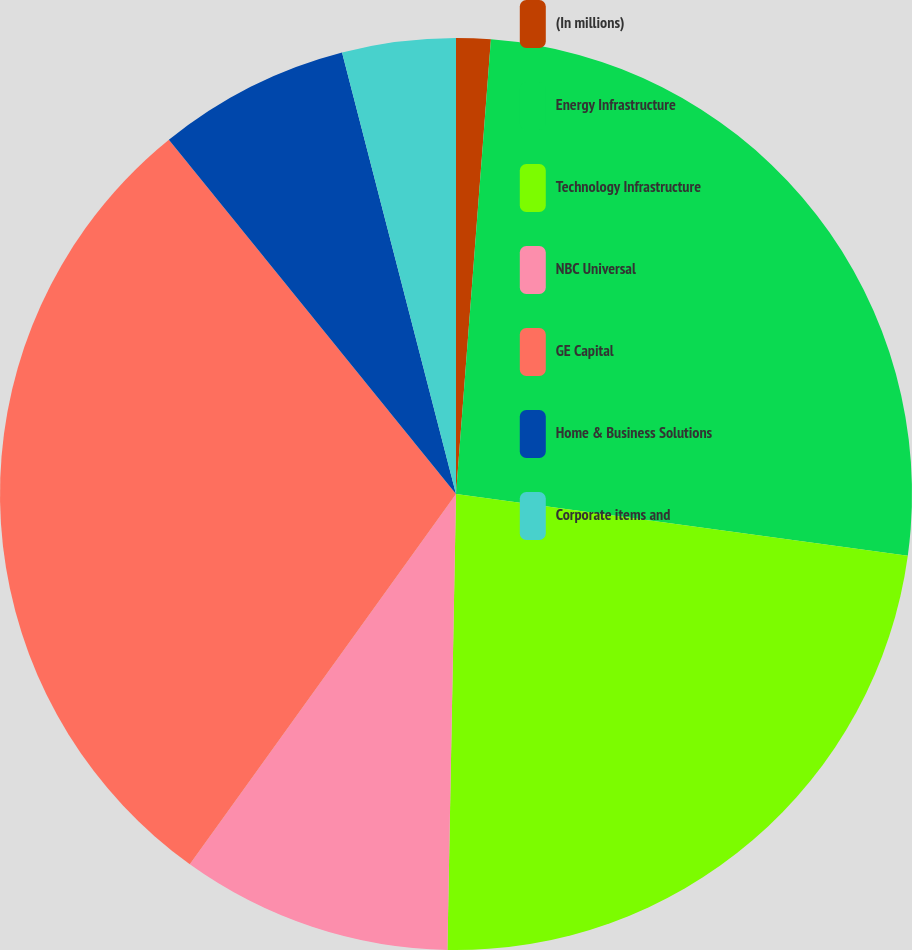Convert chart to OTSL. <chart><loc_0><loc_0><loc_500><loc_500><pie_chart><fcel>(In millions)<fcel>Energy Infrastructure<fcel>Technology Infrastructure<fcel>NBC Universal<fcel>GE Capital<fcel>Home & Business Solutions<fcel>Corporate items and<nl><fcel>1.22%<fcel>25.94%<fcel>23.14%<fcel>9.62%<fcel>29.24%<fcel>6.82%<fcel>4.02%<nl></chart> 